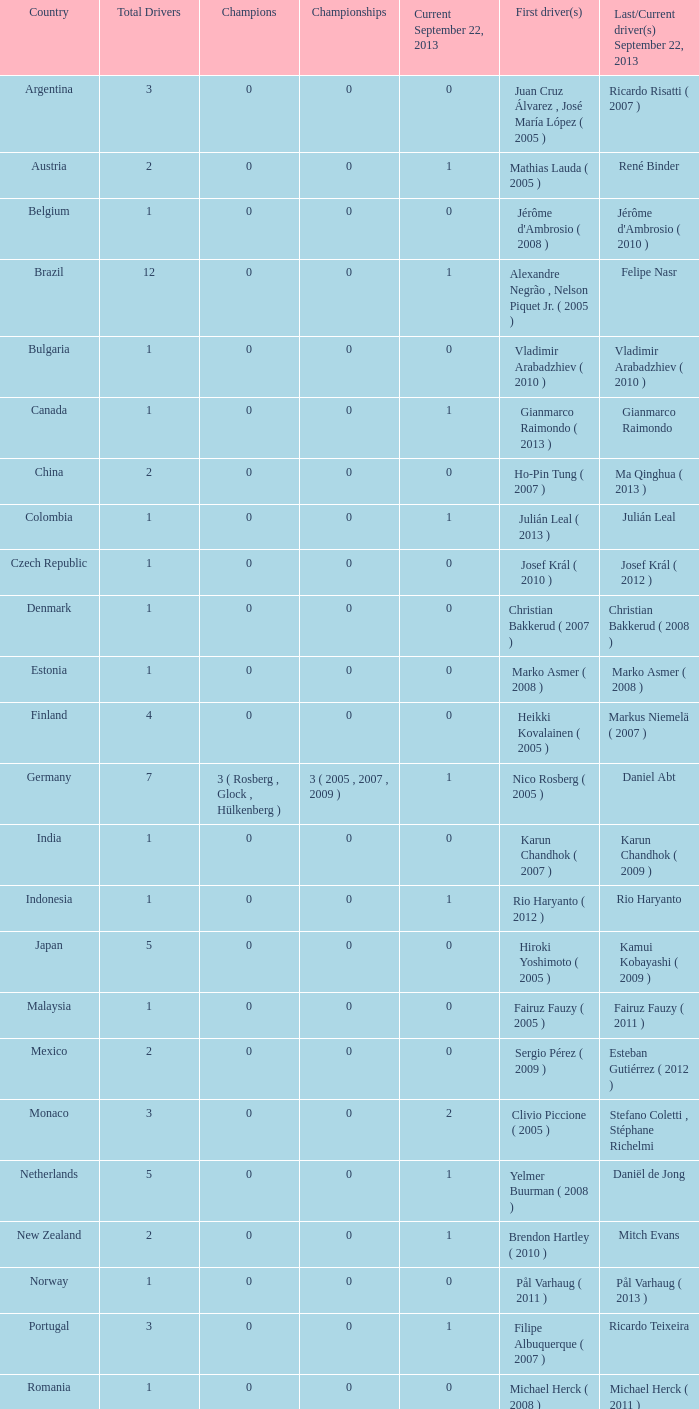How many entries are there for first driver for Canada? 1.0. 